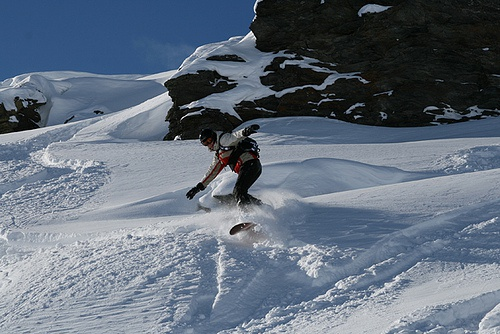Describe the objects in this image and their specific colors. I can see people in blue, black, gray, darkgray, and maroon tones and snowboard in blue, black, gray, and maroon tones in this image. 